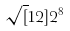Convert formula to latex. <formula><loc_0><loc_0><loc_500><loc_500>\sqrt { [ } 1 2 ] { 2 ^ { 8 } }</formula> 